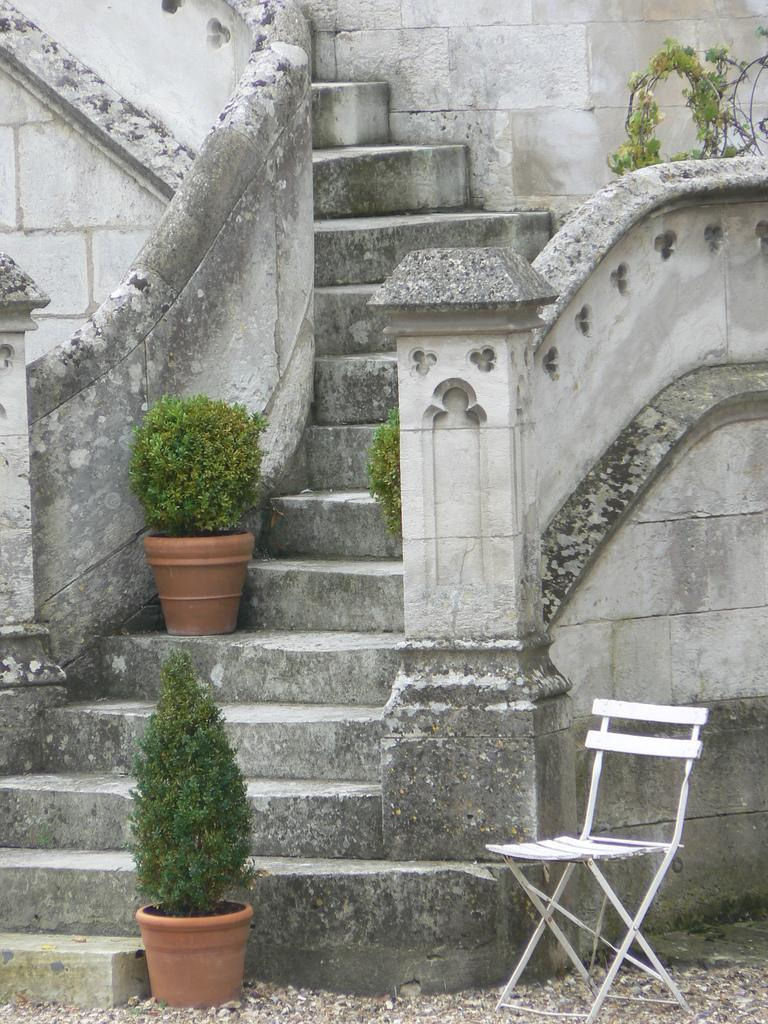What type of structure is present in the image? There are stairs in the image, which belong to a building. What other objects can be seen in the image? There is a chair and plant pots visible in the image. What type of skin is visible on the chair in the image? There is no skin visible in the image; the chair is an inanimate object. 